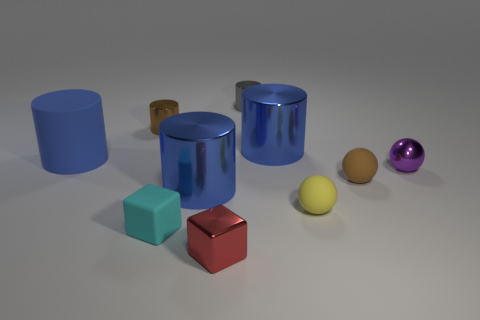There is a brown object that is behind the purple ball; is it the same size as the cylinder on the left side of the brown cylinder?
Your answer should be compact. No. Are there more rubber balls that are in front of the small gray cylinder than brown shiny cylinders in front of the yellow object?
Keep it short and to the point. Yes. How many other things are the same color as the big matte cylinder?
Your response must be concise. 2. Is the color of the big rubber thing the same as the large cylinder right of the metallic block?
Ensure brevity in your answer.  Yes. There is a large blue matte object in front of the brown shiny object; what number of blue metallic cylinders are on the left side of it?
Give a very brief answer. 0. What material is the brown thing that is on the right side of the blue metallic cylinder that is on the left side of the blue object behind the large matte cylinder?
Provide a short and direct response. Rubber. There is a big blue thing that is to the left of the red block and behind the purple shiny ball; what is its material?
Ensure brevity in your answer.  Rubber. What number of other shiny objects are the same shape as the red shiny thing?
Make the answer very short. 0. There is a cylinder in front of the big blue cylinder that is to the left of the tiny cyan thing; what is its size?
Your answer should be very brief. Large. There is a large metallic thing that is to the right of the red shiny cube; is its color the same as the cylinder that is in front of the big blue rubber object?
Keep it short and to the point. Yes. 